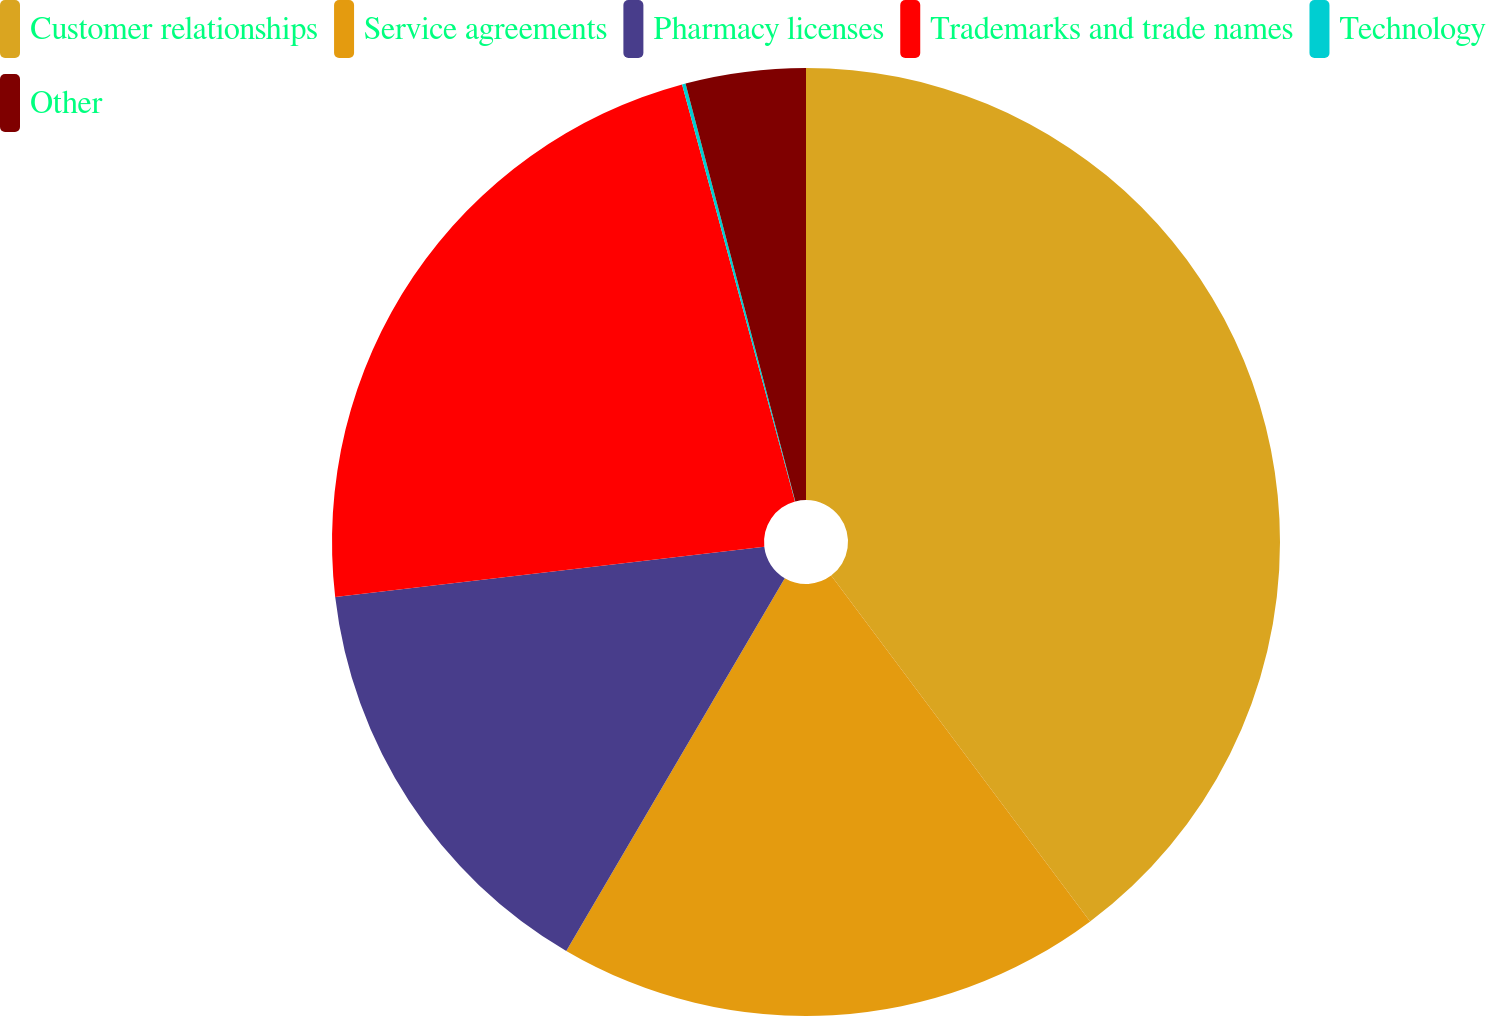Convert chart. <chart><loc_0><loc_0><loc_500><loc_500><pie_chart><fcel>Customer relationships<fcel>Service agreements<fcel>Pharmacy licenses<fcel>Trademarks and trade names<fcel>Technology<fcel>Other<nl><fcel>39.77%<fcel>18.67%<fcel>14.71%<fcel>22.64%<fcel>0.12%<fcel>4.09%<nl></chart> 